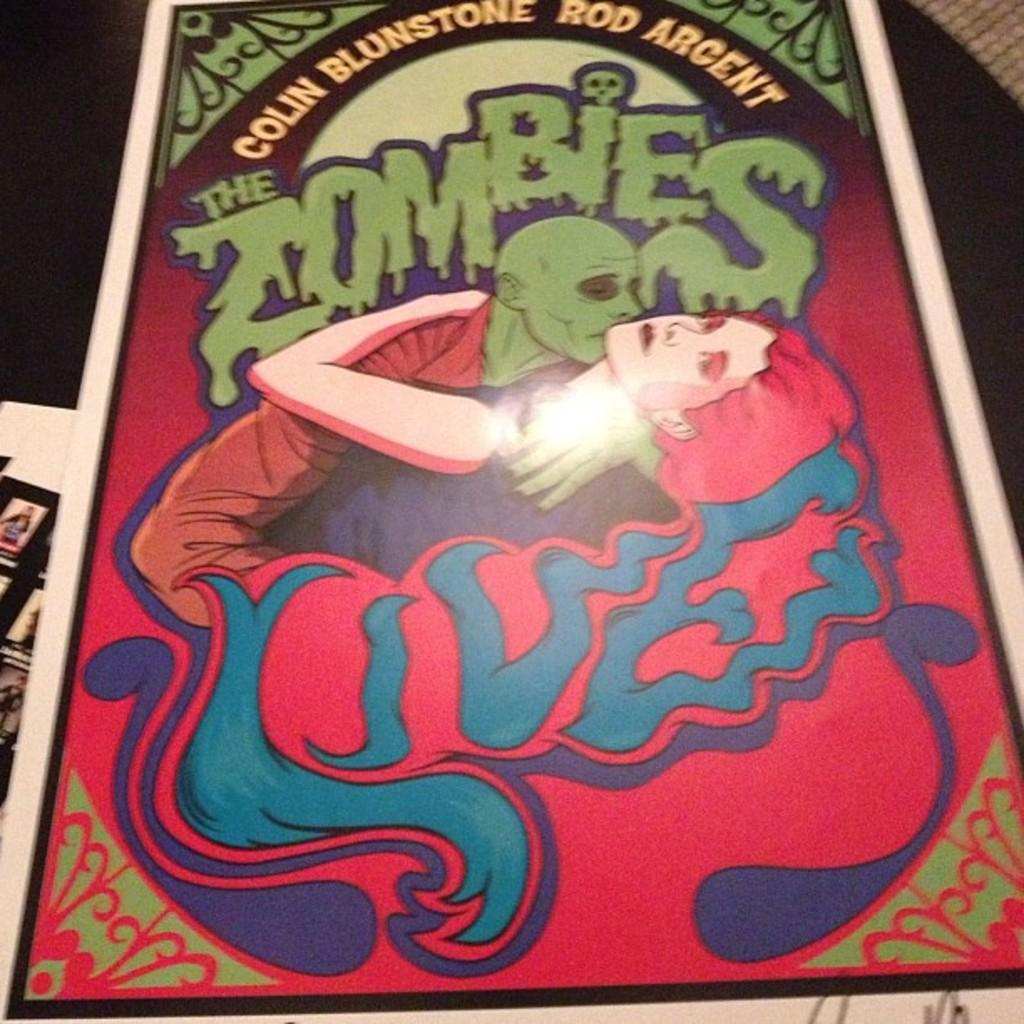What type of card is in the image? There is a colorful card in the image. What is depicted on the card? The card has an image of zombies. Are there any words on the card? Yes, there is text printed on the card. What can be seen in the background of the image? There are other cards visible in the background. What color is the surface behind the cards? The background surface is black. What type of mark can be seen on the zombie's forehead in the image? There is no mark visible on the zombie's forehead in the image. 